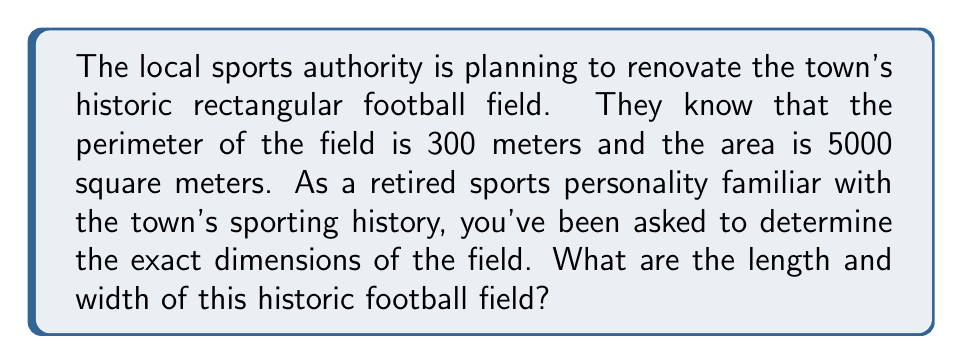Could you help me with this problem? Let's approach this step-by-step:

1) Let's define our variables:
   $l$ = length of the field
   $w$ = width of the field

2) We can set up two equations based on the given information:
   
   Perimeter equation: $2l + 2w = 300$ (Equation 1)
   Area equation: $lw = 5000$ (Equation 2)

3) From Equation 1, we can express $l$ in terms of $w$:
   $2l + 2w = 300$
   $2l = 300 - 2w$
   $l = 150 - w$ (Equation 3)

4) Now, let's substitute this expression for $l$ into Equation 2:
   $(150 - w)w = 5000$

5) Expand this equation:
   $150w - w^2 = 5000$

6) Rearrange to standard quadratic form:
   $w^2 - 150w + 5000 = 0$

7) This is a quadratic equation. We can solve it using the quadratic formula:
   $w = \frac{-b \pm \sqrt{b^2 - 4ac}}{2a}$

   Where $a = 1$, $b = -150$, and $c = 5000$

8) Plugging in these values:
   $w = \frac{150 \pm \sqrt{150^2 - 4(1)(5000)}}{2(1)}$
   $w = \frac{150 \pm \sqrt{22500 - 20000}}{2}$
   $w = \frac{150 \pm \sqrt{2500}}{2}$
   $w = \frac{150 \pm 50}{2}$

9) This gives us two solutions:
   $w = \frac{150 + 50}{2} = 100$ or $w = \frac{150 - 50}{2} = 50$

10) Since width can't be larger than length in a rectangle, $w = 50$ meters.

11) We can find $l$ by substituting this value of $w$ into Equation 3:
    $l = 150 - 50 = 100$ meters

Therefore, the dimensions of the field are 100 meters long and 50 meters wide.
Answer: The historic football field is 100 meters long and 50 meters wide. 